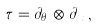<formula> <loc_0><loc_0><loc_500><loc_500>\tau = \partial _ { \theta _ { i } } \otimes \partial _ { x _ { i } } ,</formula> 